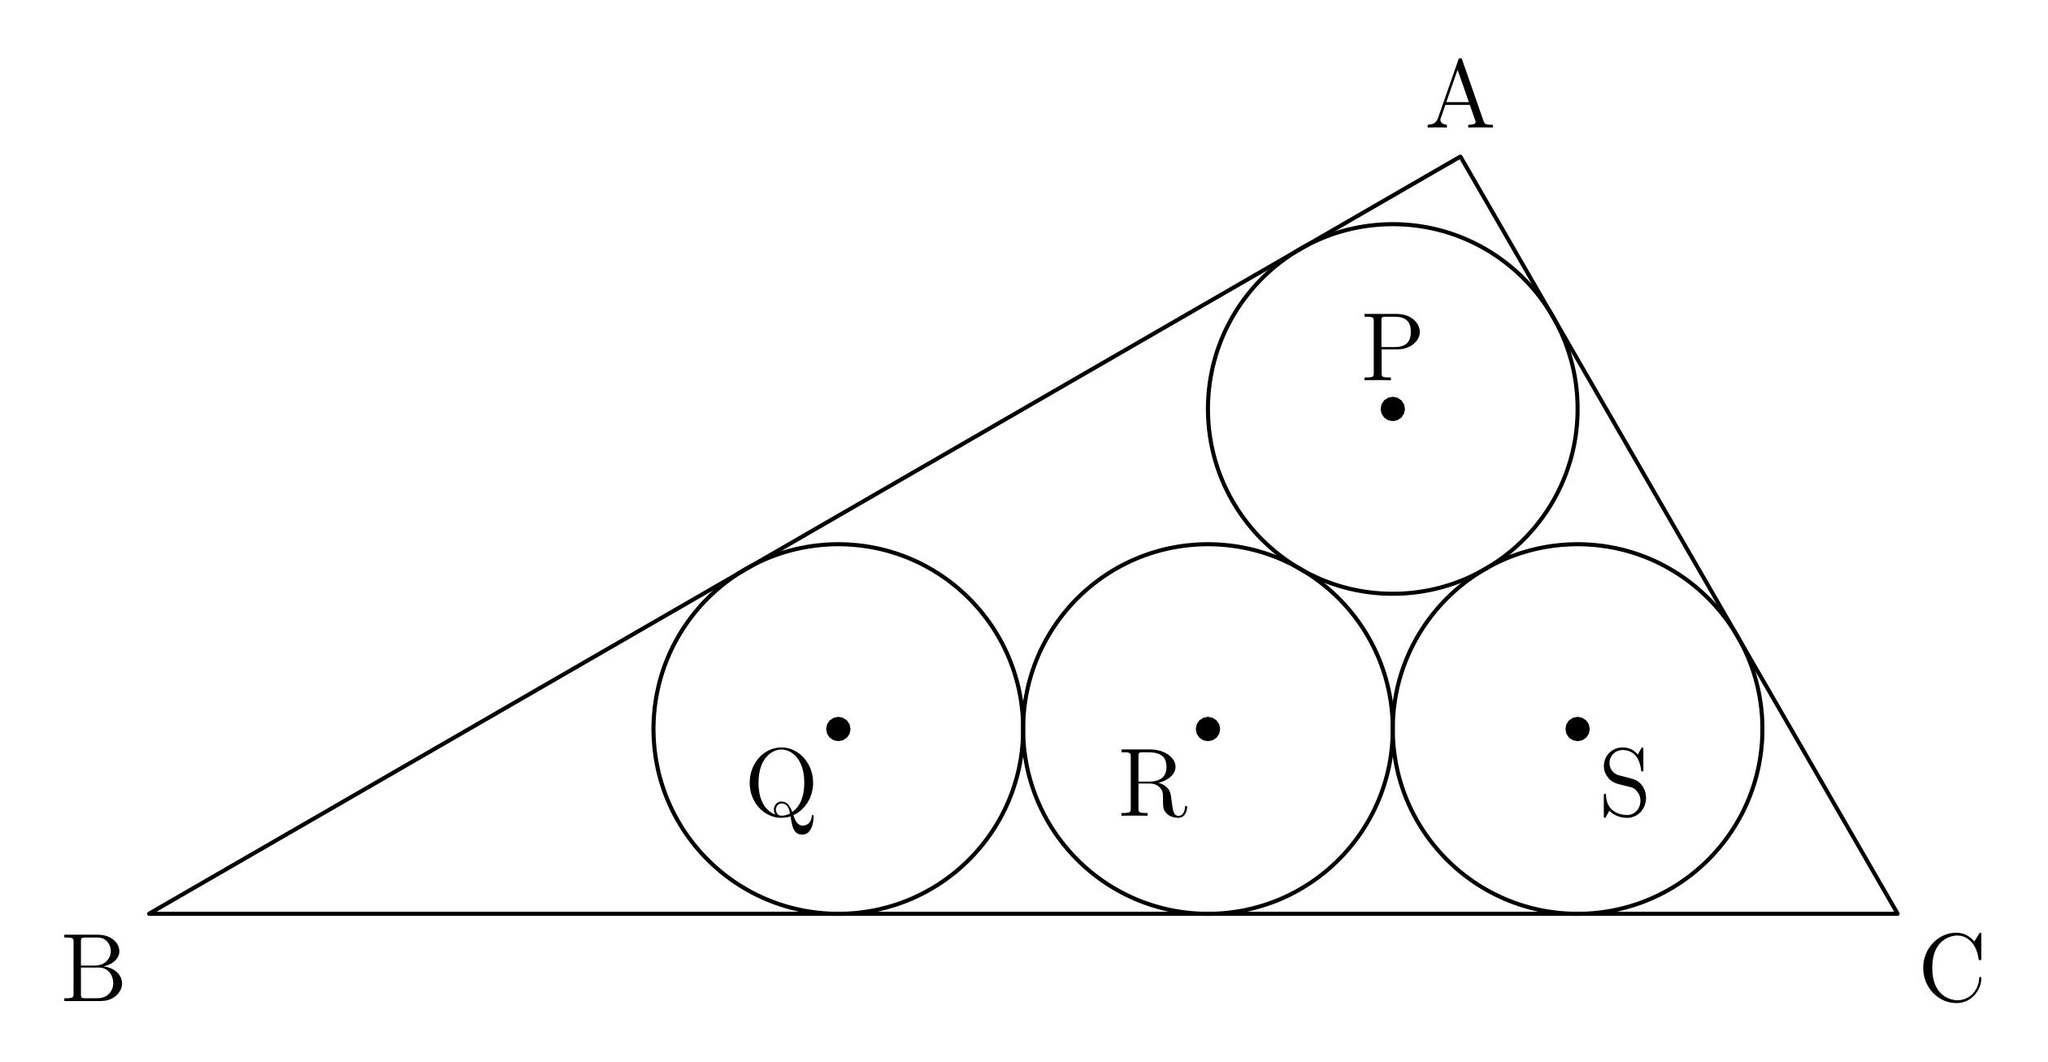Can you explain why circles P, Q, R, S are tangent to each other and how this affects their positions? The circles P, Q, R, and S are each tangent to two others because their centers are spaced exactly two radii apart, a common configuration in geometric designs that maximizes symmetrical placement while minimizing the space used. This positioning ensures that each circle touches another without any gaps, which is critical in problems involving packing and covering like this one. Their tangency to triangle ABC's sides further restricts their positions, enforcing a symmetrical and balanced layout within the triangle. 